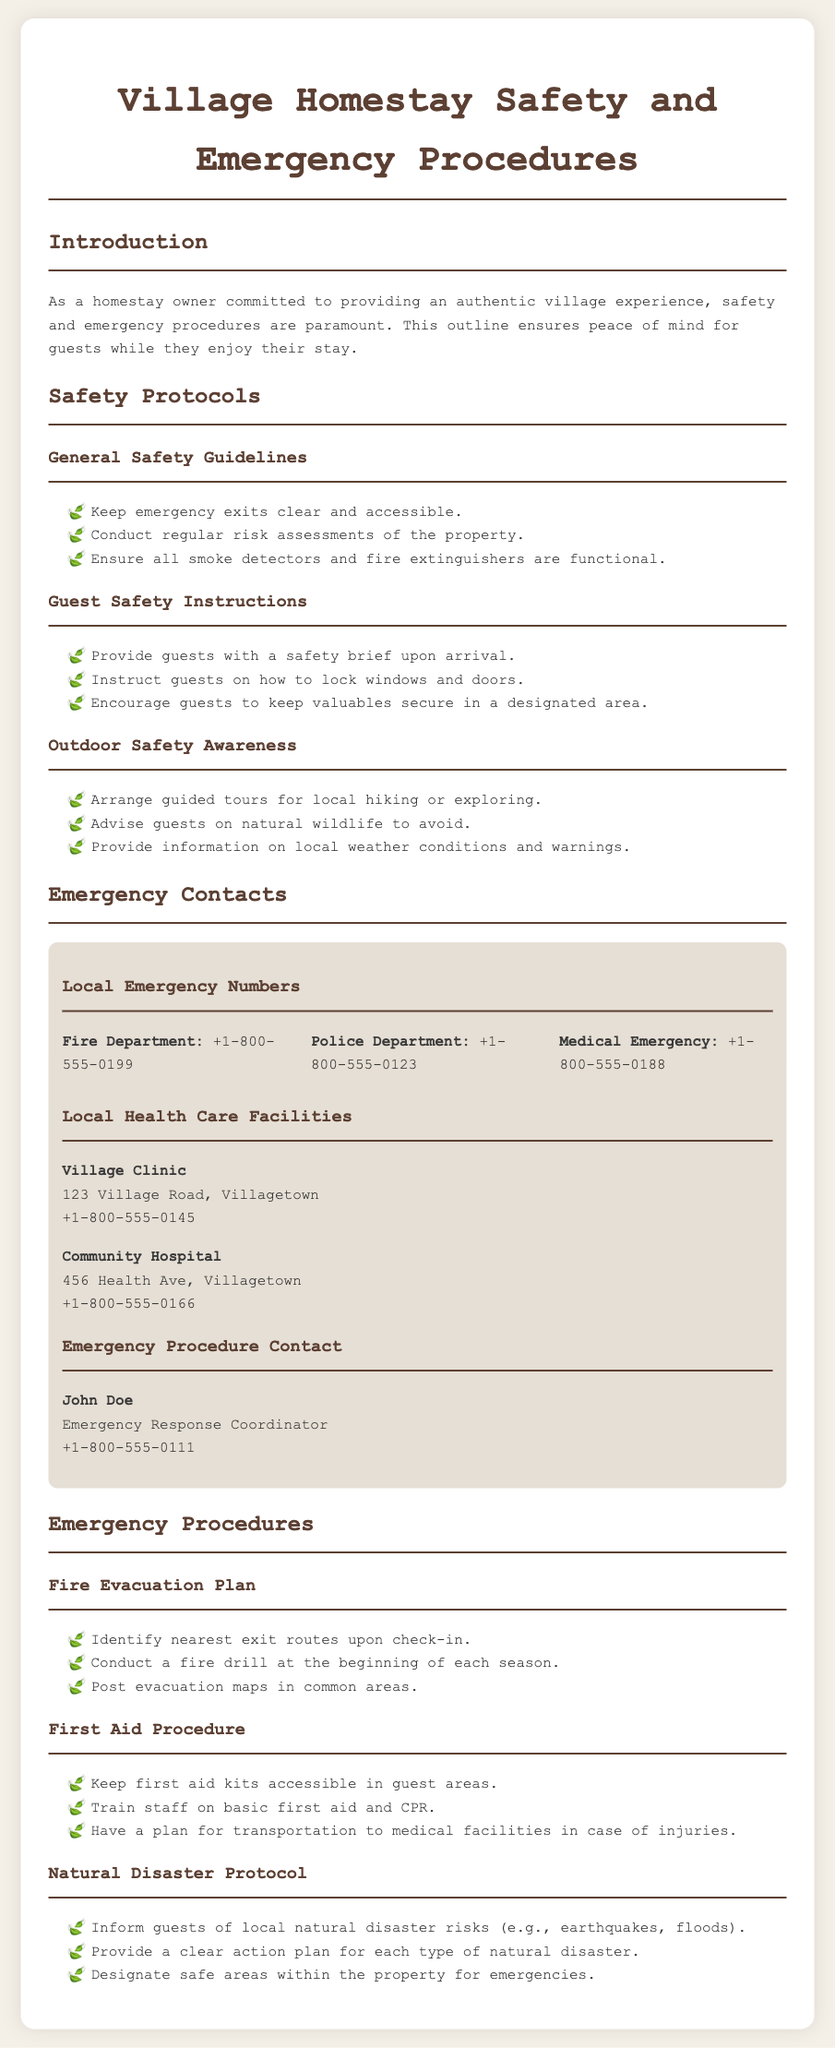what is the title of the document? The title of the document is indicated in the heading tag.
Answer: Village Homestay Safety and Emergency Procedures who is the Emergency Response Coordinator? The coordinator's name is listed under the Emergency Procedure Contact section.
Answer: John Doe what is the contact number for the Fire Department? The contact number is provided in the Local Emergency Numbers section.
Answer: +1-800-555-0199 how often are fire drills conducted? The frequency of drills is outlined in the Fire Evacuation Plan section.
Answer: at the beginning of each season what should guests do with their valuables? The response is found in the Guest Safety Instructions section.
Answer: keep valuables secure in a designated area what local health care facility is mentioned first? The first facility listed under Local Health Care Facilities gives this information.
Answer: Village Clinic what is the main purpose of the document? The purpose of the document is summarized in the introduction.
Answer: ensuring peace of mind for guests what natural disaster risks should guests be informed about? The specific risks are detailed in the Natural Disaster Protocol section.
Answer: earthquakes, floods 